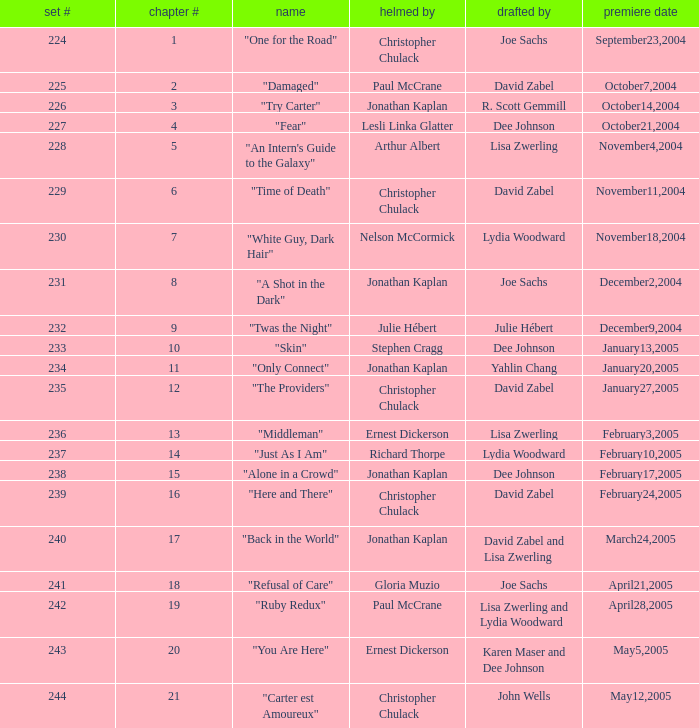Name who wrote the episode directed by arthur albert Lisa Zwerling. 